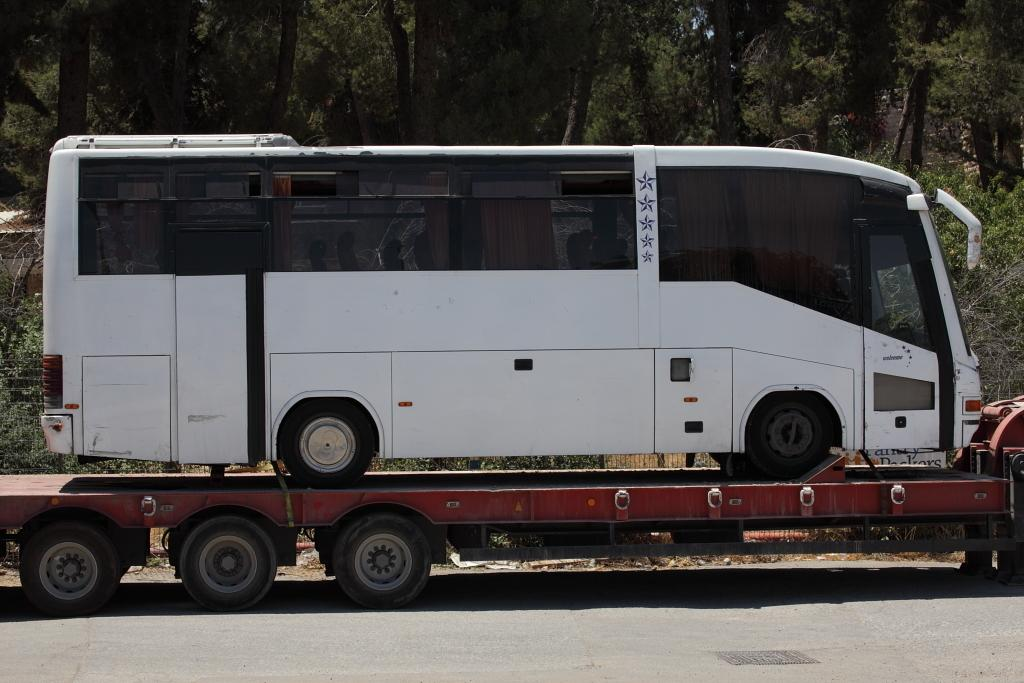What type of vegetation can be seen in the background of the image? There are trees in the background of the image. What mode of transportation is present in the image? There is a bus in the image. Where is the bus located in the image? The bus is on a platform. What is the purpose of the platform in the image? The platform is for vehicles. What can be seen at the bottom portion of the image? There is a road visible at the bottom portion of the image. Can you tell me how many sponges are on the bus in the image? There are no sponges present on the bus in the image. What type of wish is granted to the passengers on the bus in the image? There is no mention of wishes or any magical elements in the image; it simply shows a bus on a platform. 